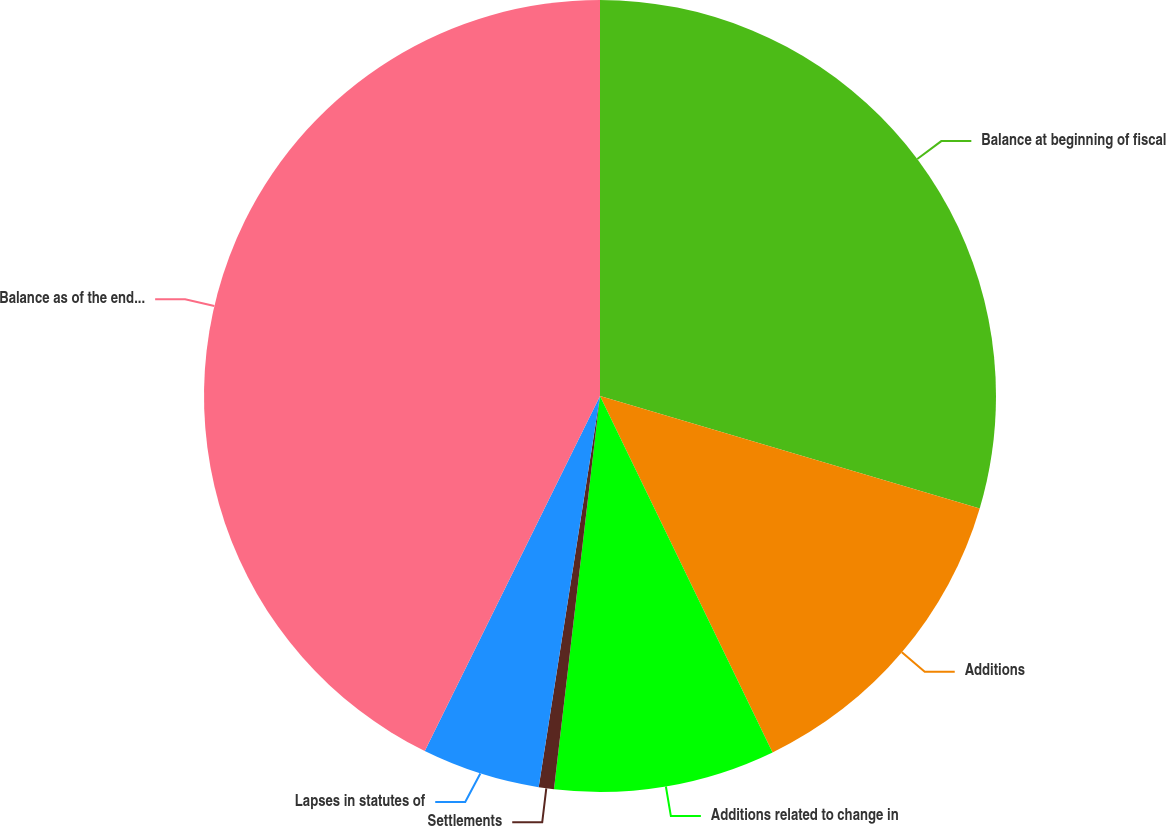<chart> <loc_0><loc_0><loc_500><loc_500><pie_chart><fcel>Balance at beginning of fiscal<fcel>Additions<fcel>Additions related to change in<fcel>Settlements<fcel>Lapses in statutes of<fcel>Balance as of the end of the<nl><fcel>29.58%<fcel>13.24%<fcel>9.03%<fcel>0.62%<fcel>4.82%<fcel>42.7%<nl></chart> 